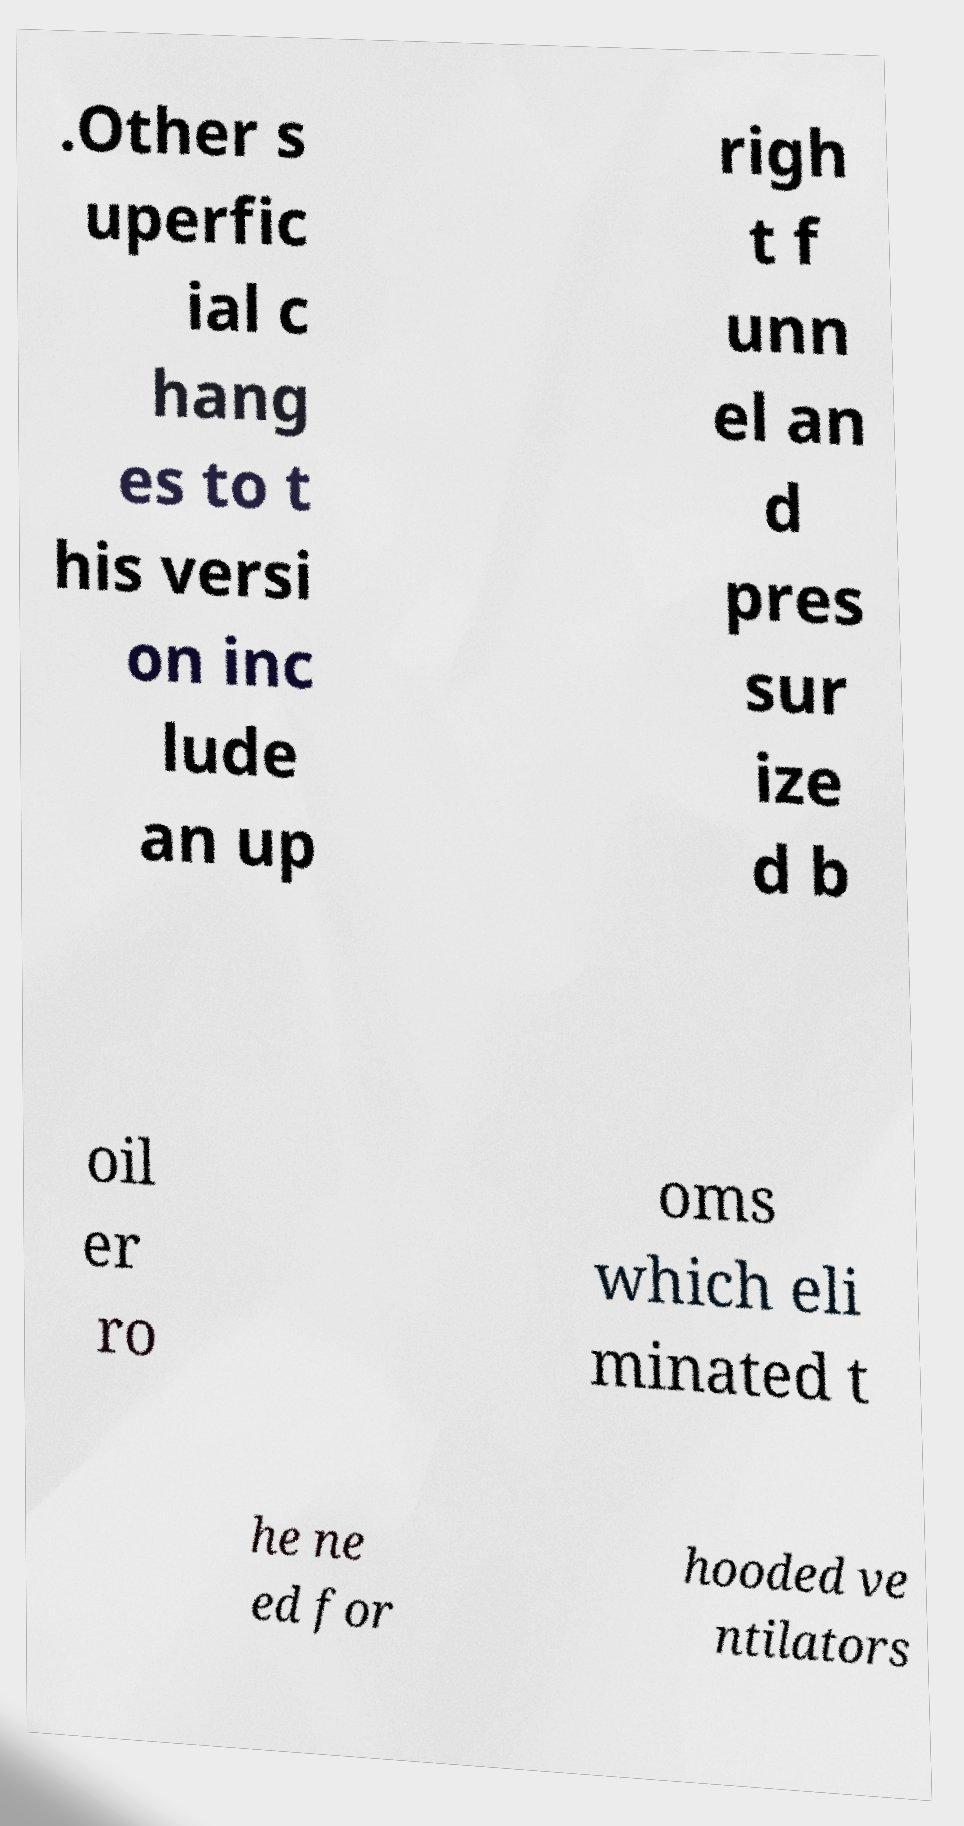Can you accurately transcribe the text from the provided image for me? .Other s uperfic ial c hang es to t his versi on inc lude an up righ t f unn el an d pres sur ize d b oil er ro oms which eli minated t he ne ed for hooded ve ntilators 